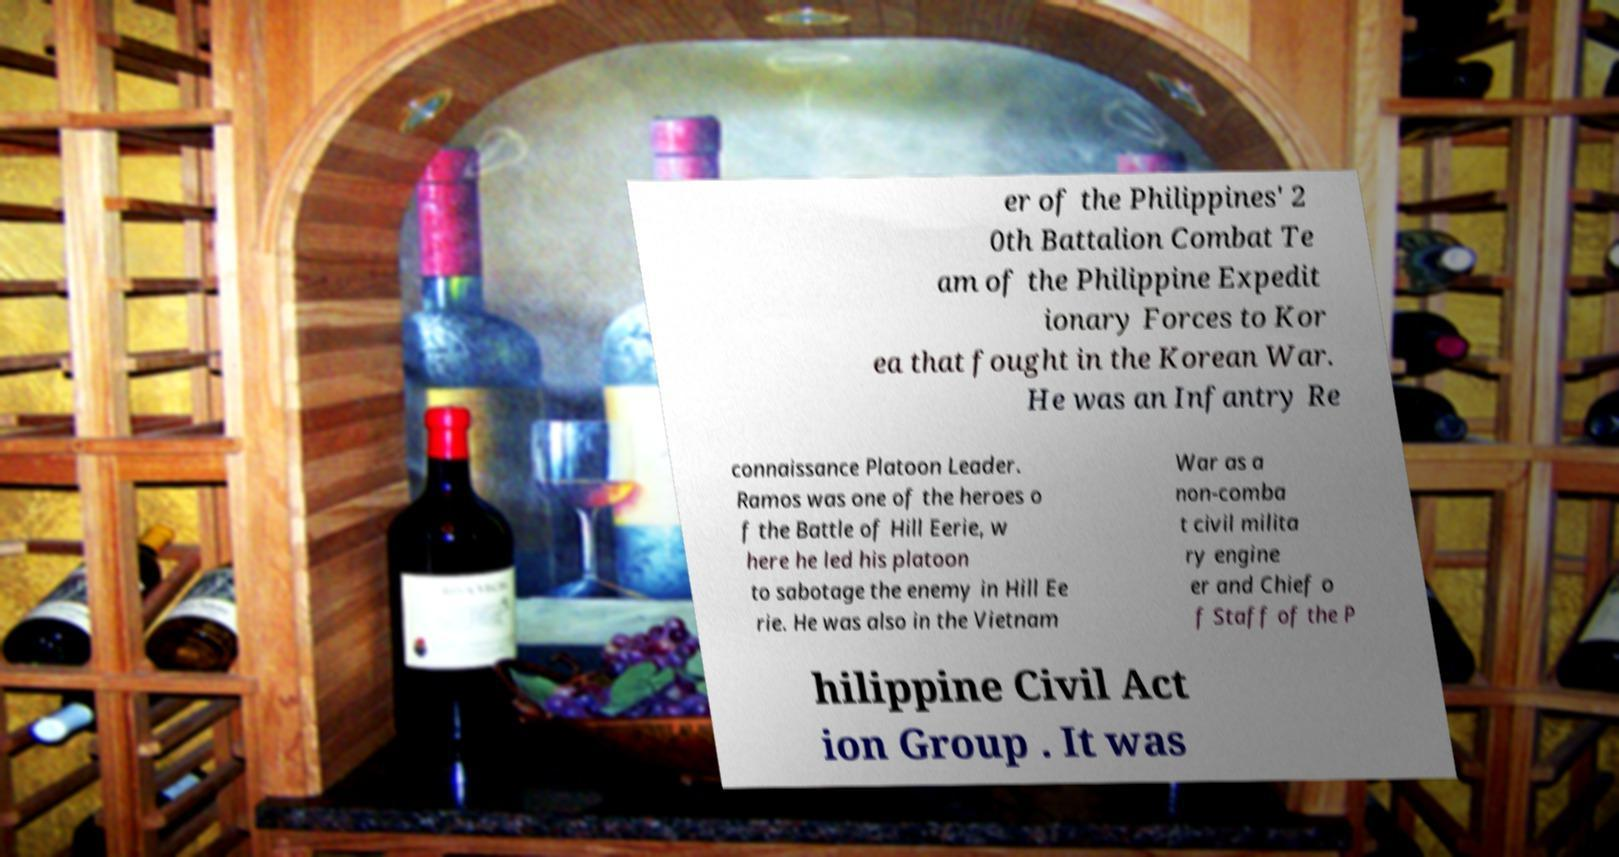Can you accurately transcribe the text from the provided image for me? er of the Philippines' 2 0th Battalion Combat Te am of the Philippine Expedit ionary Forces to Kor ea that fought in the Korean War. He was an Infantry Re connaissance Platoon Leader. Ramos was one of the heroes o f the Battle of Hill Eerie, w here he led his platoon to sabotage the enemy in Hill Ee rie. He was also in the Vietnam War as a non-comba t civil milita ry engine er and Chief o f Staff of the P hilippine Civil Act ion Group . It was 